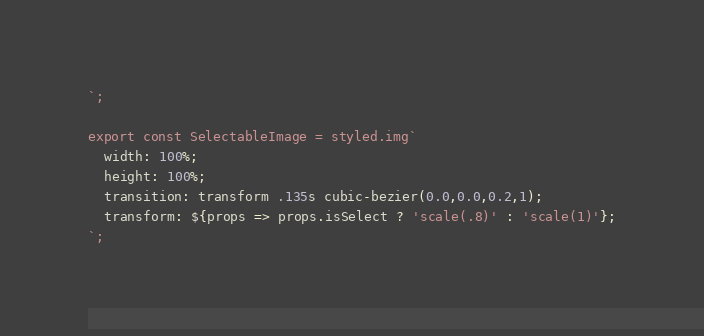<code> <loc_0><loc_0><loc_500><loc_500><_JavaScript_>`;

export const SelectableImage = styled.img`
  width: 100%;
  height: 100%;
  transition: transform .135s cubic-bezier(0.0,0.0,0.2,1);
  transform: ${props => props.isSelect ? 'scale(.8)' : 'scale(1)'};
`;
</code> 